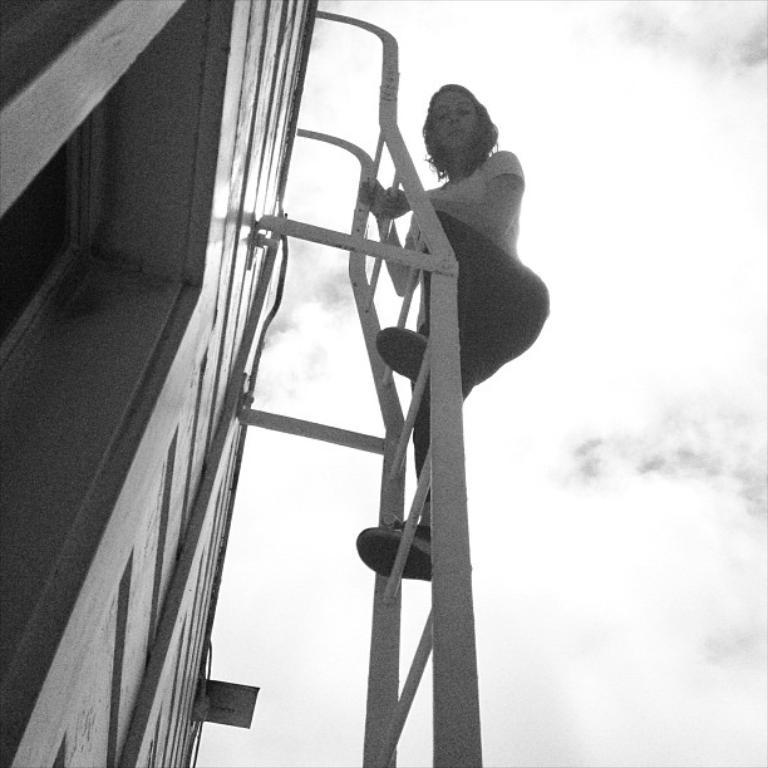Who is present in the image? There is a woman in the image. What is the woman doing in the image? The woman is standing on a ladder. How is the ladder positioned in the image? The ladder is attached to a wall. What is the color scheme of the image? The image is black and white. What can be seen in the background of the image? There is sky visible in the image, and there are clouds in the sky. How many girls are playing with the net in the image? There are no girls or nets present in the image. 